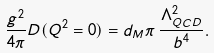Convert formula to latex. <formula><loc_0><loc_0><loc_500><loc_500>\frac { g ^ { 2 } } { 4 \pi } D ( Q ^ { 2 } = 0 ) = d _ { M } \pi \, \frac { \Lambda _ { Q C D } ^ { 2 } } { b ^ { 4 } } .</formula> 